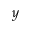<formula> <loc_0><loc_0><loc_500><loc_500>y</formula> 